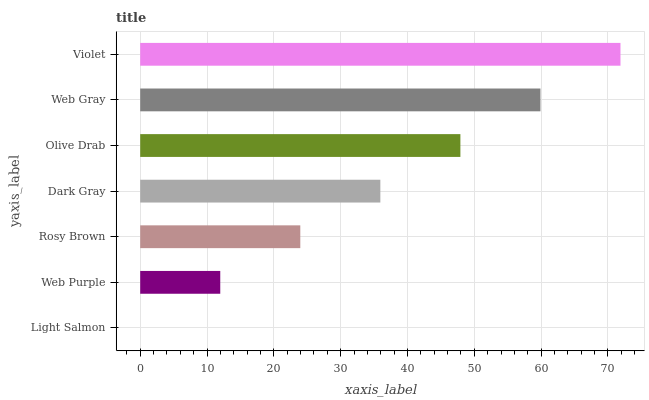Is Light Salmon the minimum?
Answer yes or no. Yes. Is Violet the maximum?
Answer yes or no. Yes. Is Web Purple the minimum?
Answer yes or no. No. Is Web Purple the maximum?
Answer yes or no. No. Is Web Purple greater than Light Salmon?
Answer yes or no. Yes. Is Light Salmon less than Web Purple?
Answer yes or no. Yes. Is Light Salmon greater than Web Purple?
Answer yes or no. No. Is Web Purple less than Light Salmon?
Answer yes or no. No. Is Dark Gray the high median?
Answer yes or no. Yes. Is Dark Gray the low median?
Answer yes or no. Yes. Is Rosy Brown the high median?
Answer yes or no. No. Is Rosy Brown the low median?
Answer yes or no. No. 